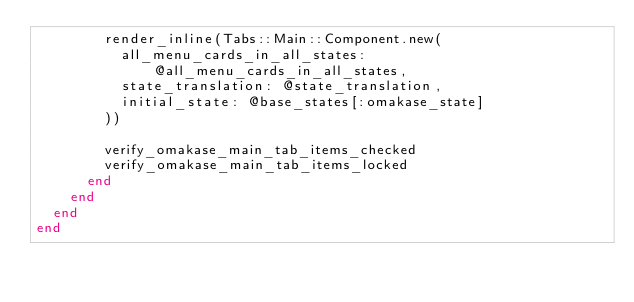Convert code to text. <code><loc_0><loc_0><loc_500><loc_500><_Ruby_>        render_inline(Tabs::Main::Component.new(
          all_menu_cards_in_all_states: @all_menu_cards_in_all_states,
          state_translation: @state_translation,
          initial_state: @base_states[:omakase_state]
        ))

        verify_omakase_main_tab_items_checked
        verify_omakase_main_tab_items_locked
      end
    end
  end
end
</code> 